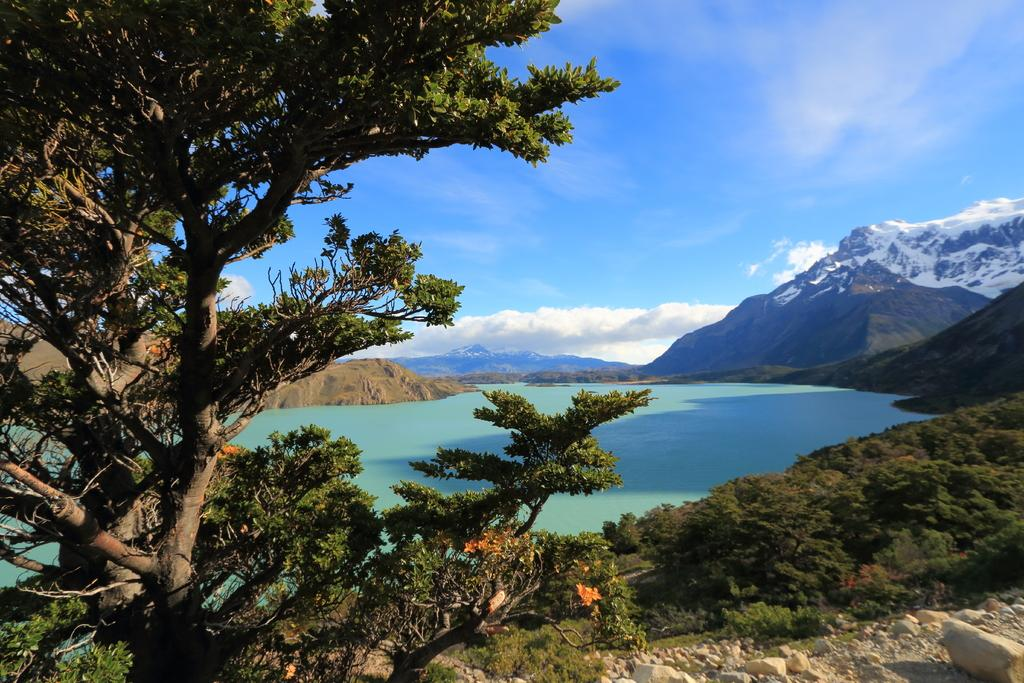What type of vegetation can be seen in the image? There are trees and bushes in the image. What body of water is present in the image? There is a lake in the image. What can be seen in the sky in the image? The sky is visible in the image. What type of landform is present in the image? There is a hill in the image. Where is the jewel hidden in the image? There is no jewel present in the image. What type of hat is the bear wearing in the image? There are no bears or hats present in the image. 